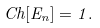Convert formula to latex. <formula><loc_0><loc_0><loc_500><loc_500>C h [ E _ { n } ] = 1 .</formula> 